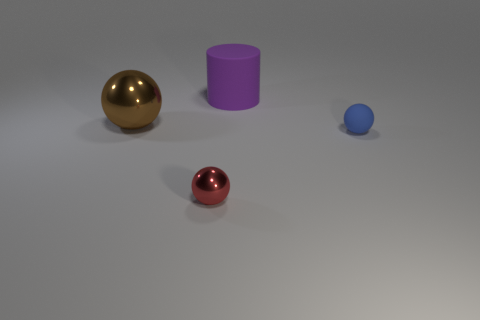Add 2 tiny blue matte spheres. How many objects exist? 6 Subtract all cylinders. How many objects are left? 3 Subtract all big matte objects. Subtract all blue objects. How many objects are left? 2 Add 4 purple rubber cylinders. How many purple rubber cylinders are left? 5 Add 1 big brown cubes. How many big brown cubes exist? 1 Subtract 0 brown blocks. How many objects are left? 4 